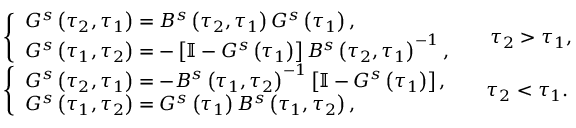<formula> <loc_0><loc_0><loc_500><loc_500>\begin{array} { r l } & { \left \{ \begin{array} { l } { G ^ { s } \left ( \tau _ { 2 } , \tau _ { 1 } \right ) = B ^ { s } \left ( \tau _ { 2 } , \tau _ { 1 } \right ) G ^ { s } \left ( \tau _ { 1 } \right ) , } \\ { G ^ { s } \left ( \tau _ { 1 } , \tau _ { 2 } \right ) = - \left [ \mathbb { I } - G ^ { s } \left ( \tau _ { 1 } \right ) \right ] B ^ { s } \left ( \tau _ { 2 } , \tau _ { 1 } \right ) ^ { - 1 } , } \end{array} \quad \tau _ { 2 } > \tau _ { 1 } , } \\ & { \left \{ \begin{array} { l } { G ^ { s } \left ( \tau _ { 2 } , \tau _ { 1 } \right ) = - B ^ { s } \left ( \tau _ { 1 } , \tau _ { 2 } \right ) ^ { - 1 } \left [ \mathbb { I } - G ^ { s } \left ( \tau _ { 1 } \right ) \right ] , } \\ { G ^ { s } \left ( \tau _ { 1 } , \tau _ { 2 } \right ) = G ^ { s } \left ( \tau _ { 1 } \right ) B ^ { s } \left ( \tau _ { 1 } , \tau _ { 2 } \right ) , } \end{array} \quad \tau _ { 2 } < \tau _ { 1 } . } \end{array}</formula> 